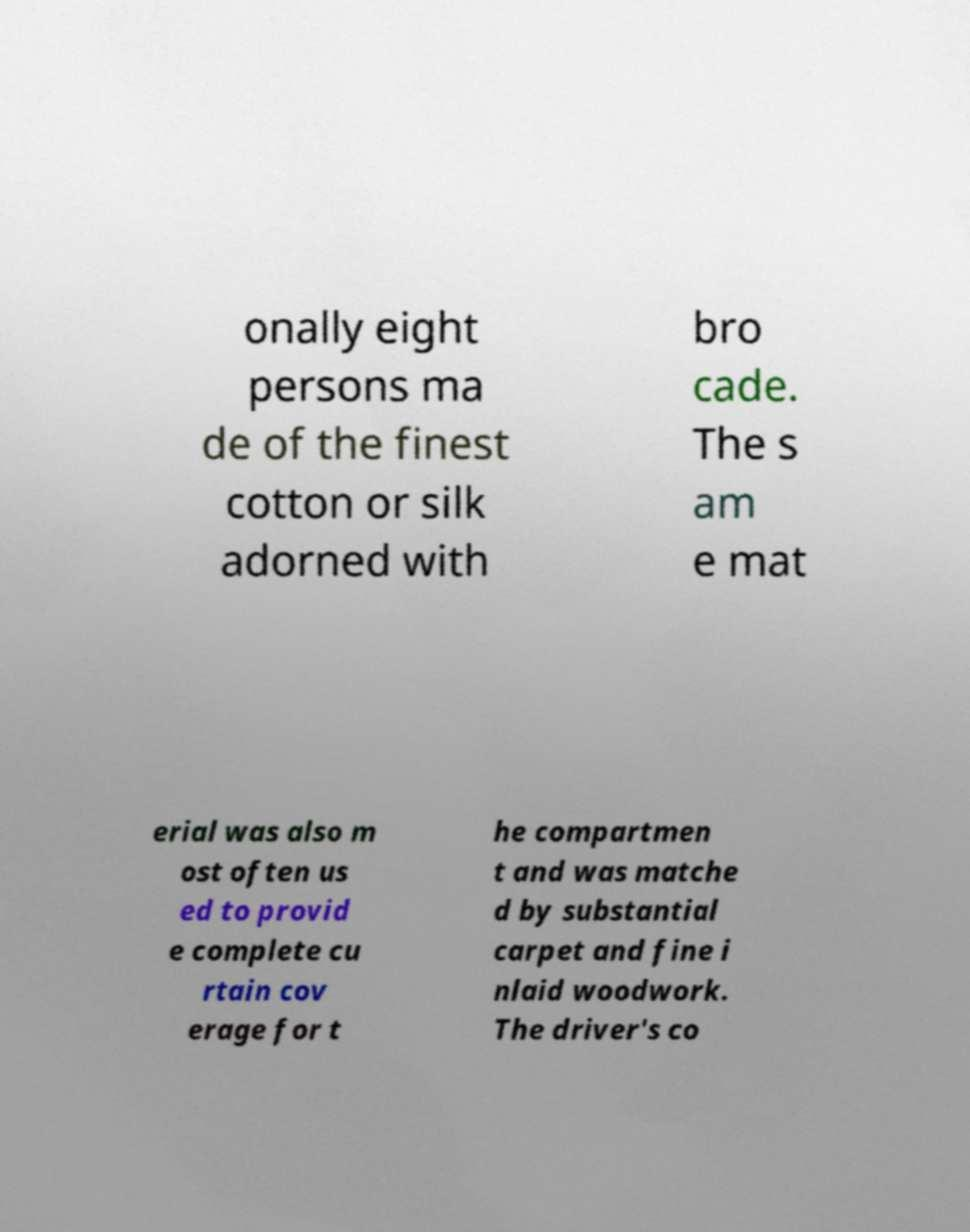Could you assist in decoding the text presented in this image and type it out clearly? onally eight persons ma de of the finest cotton or silk adorned with bro cade. The s am e mat erial was also m ost often us ed to provid e complete cu rtain cov erage for t he compartmen t and was matche d by substantial carpet and fine i nlaid woodwork. The driver's co 